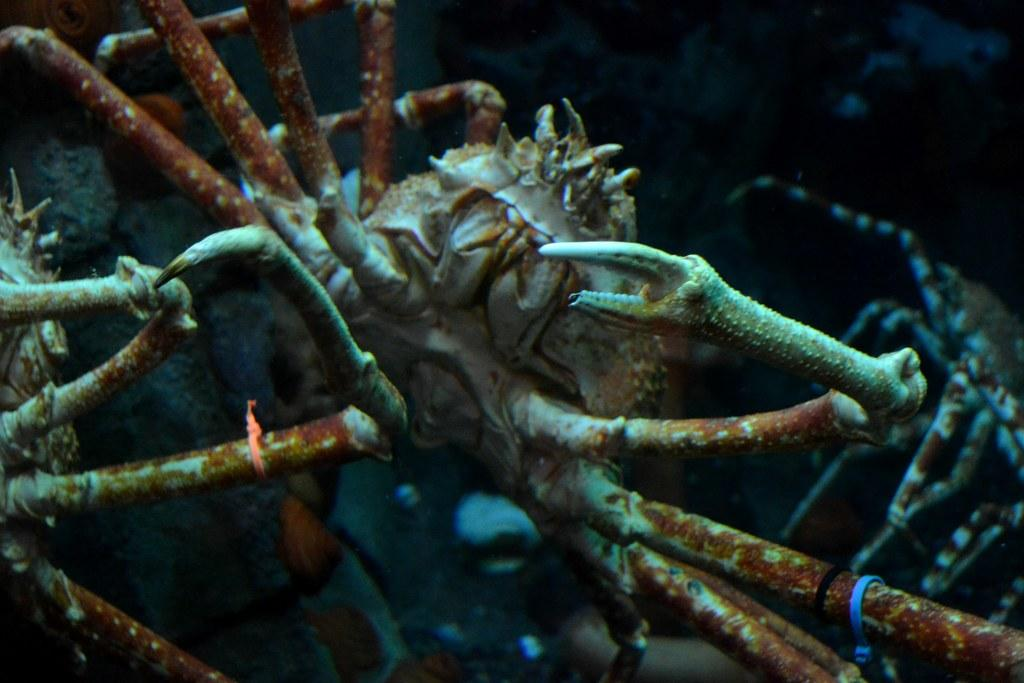What type of seafood is featured in the image? There are king crabs in the image. Can you describe the background of the image? The background of the image is dark. What type of grape is being used to make the stew in the image? There is no stew or grapes present in the image; it features king crabs with a dark background. 